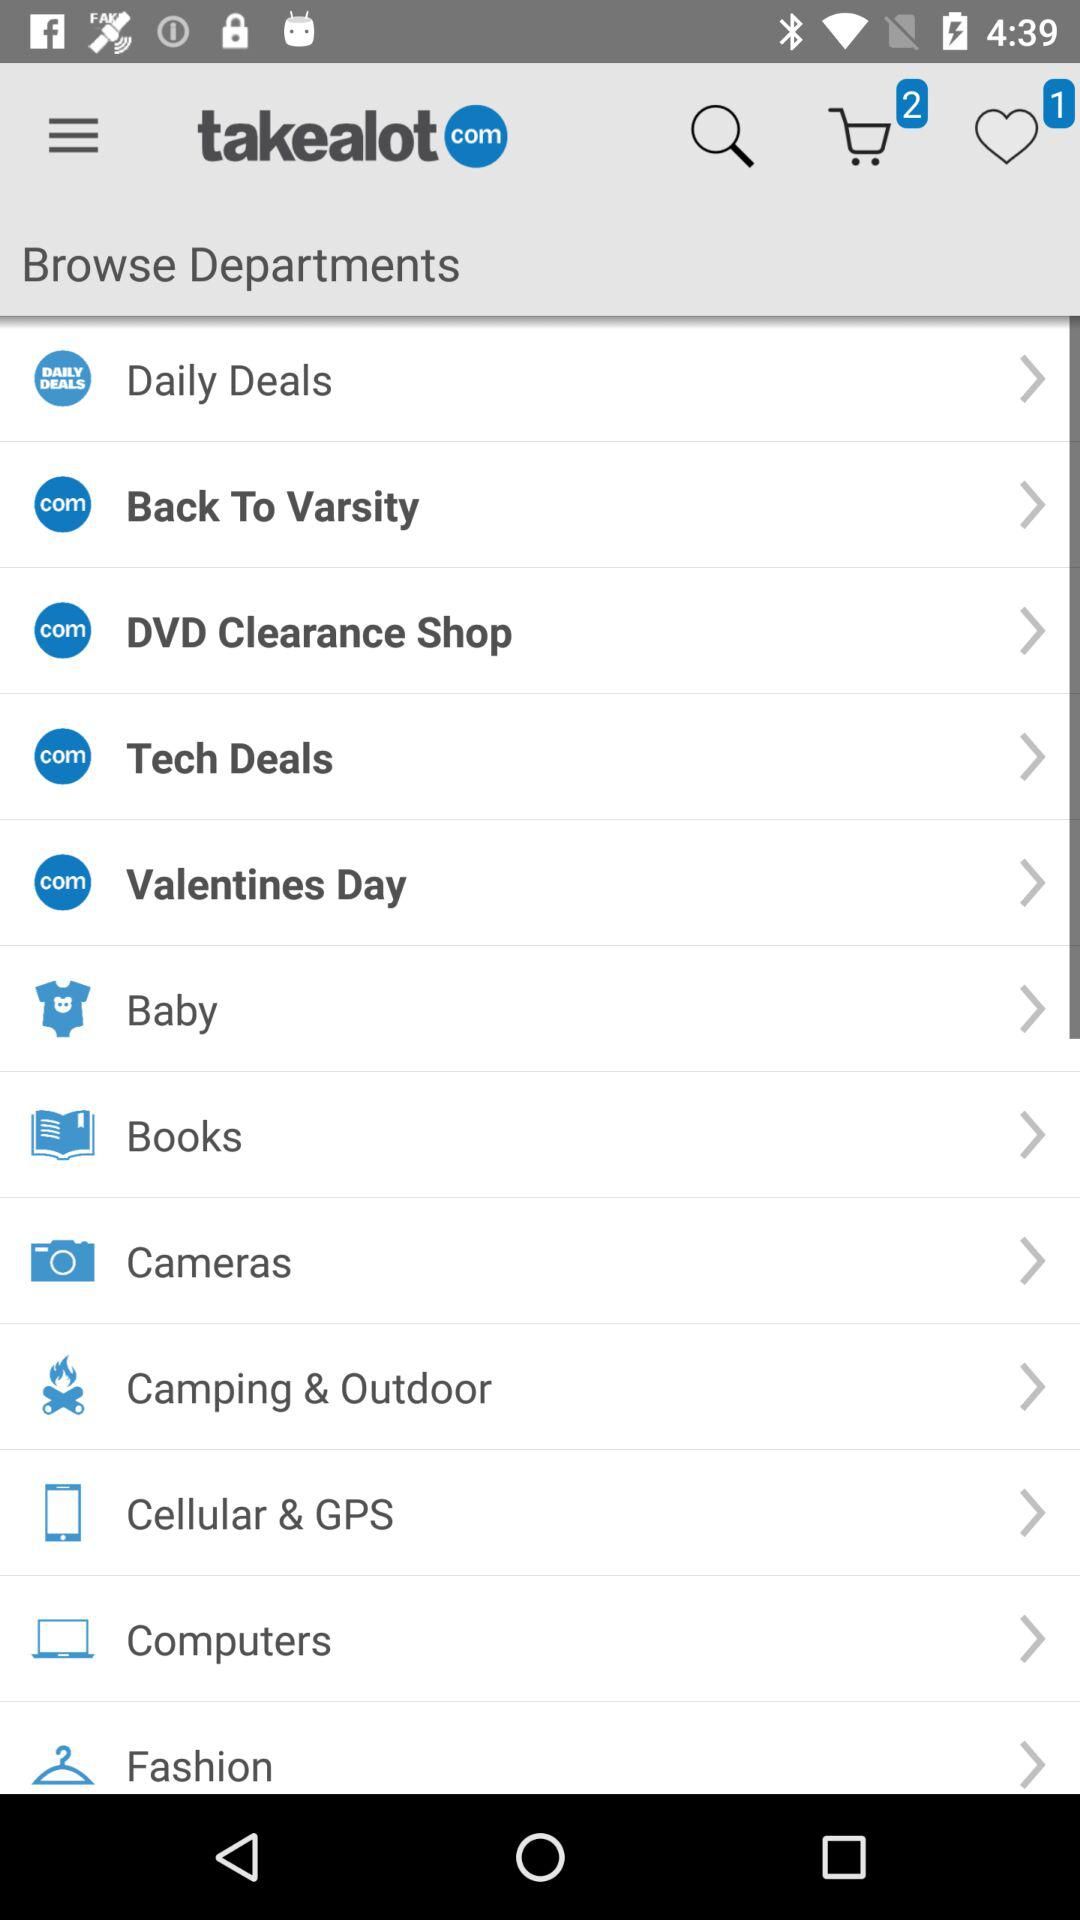How many items are added to favorites? The number of items that are added to favorites is 1. 